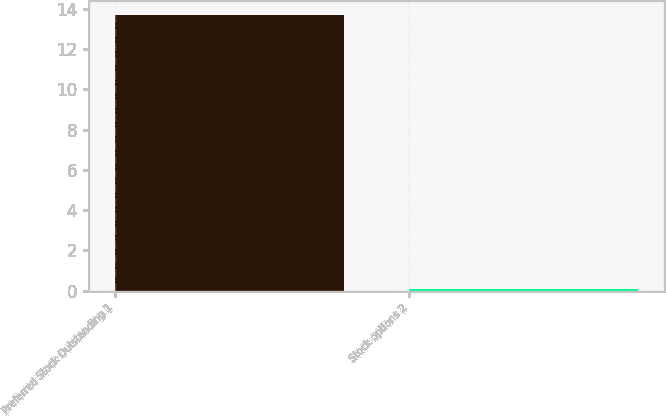Convert chart. <chart><loc_0><loc_0><loc_500><loc_500><bar_chart><fcel>Preferred Stock Outstanding 1<fcel>Stock options 2<nl><fcel>13.7<fcel>0.1<nl></chart> 